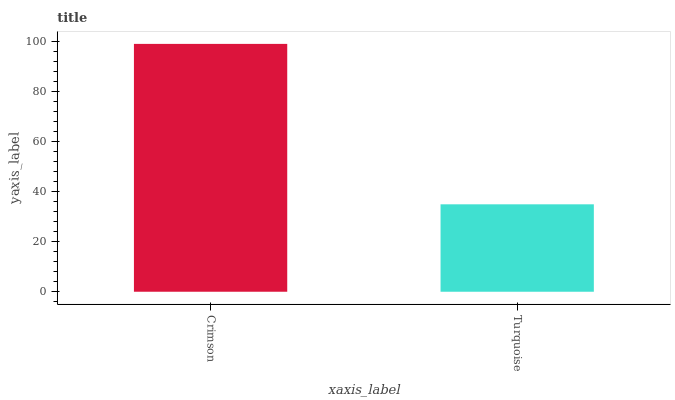Is Turquoise the minimum?
Answer yes or no. Yes. Is Crimson the maximum?
Answer yes or no. Yes. Is Turquoise the maximum?
Answer yes or no. No. Is Crimson greater than Turquoise?
Answer yes or no. Yes. Is Turquoise less than Crimson?
Answer yes or no. Yes. Is Turquoise greater than Crimson?
Answer yes or no. No. Is Crimson less than Turquoise?
Answer yes or no. No. Is Crimson the high median?
Answer yes or no. Yes. Is Turquoise the low median?
Answer yes or no. Yes. Is Turquoise the high median?
Answer yes or no. No. Is Crimson the low median?
Answer yes or no. No. 